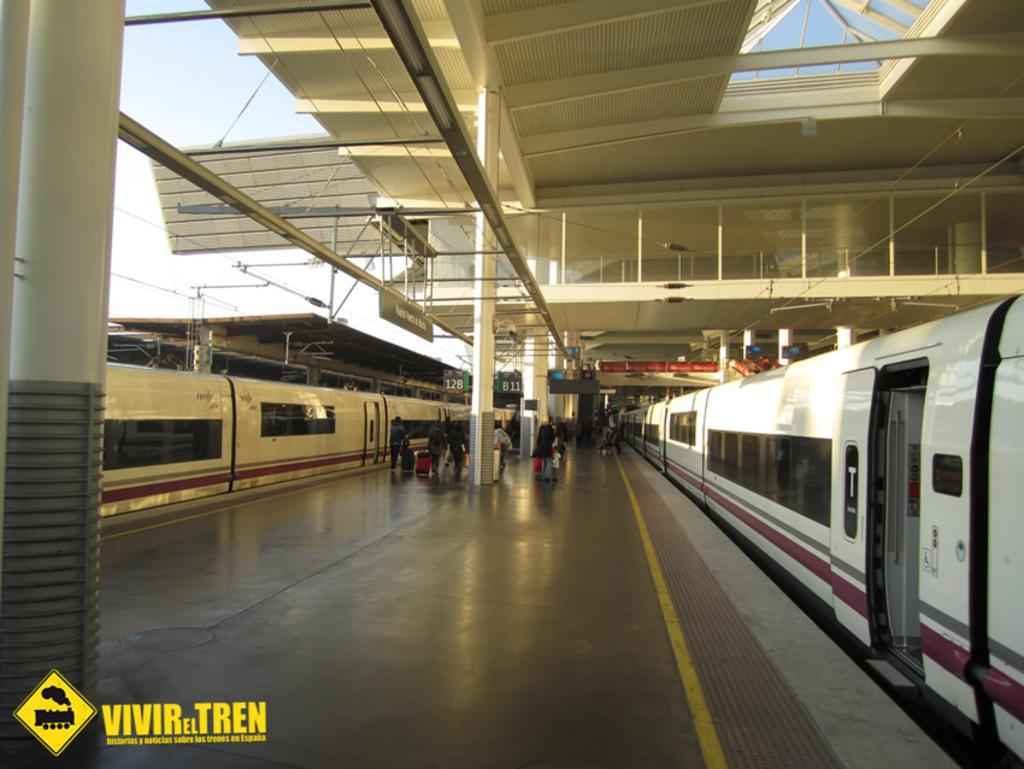What is located in the foreground of the image? There is a platform in the foreground of the image. How many trains are on the platform? Two trains are on the platform, one on each side. What can be seen in the background of the image? There are poles, a shed, cables, and the sky visible in the background of the image. What type of plate is being used to serve food on the train? There is no plate visible in the image, as it features a platform with two trains and various background elements. 